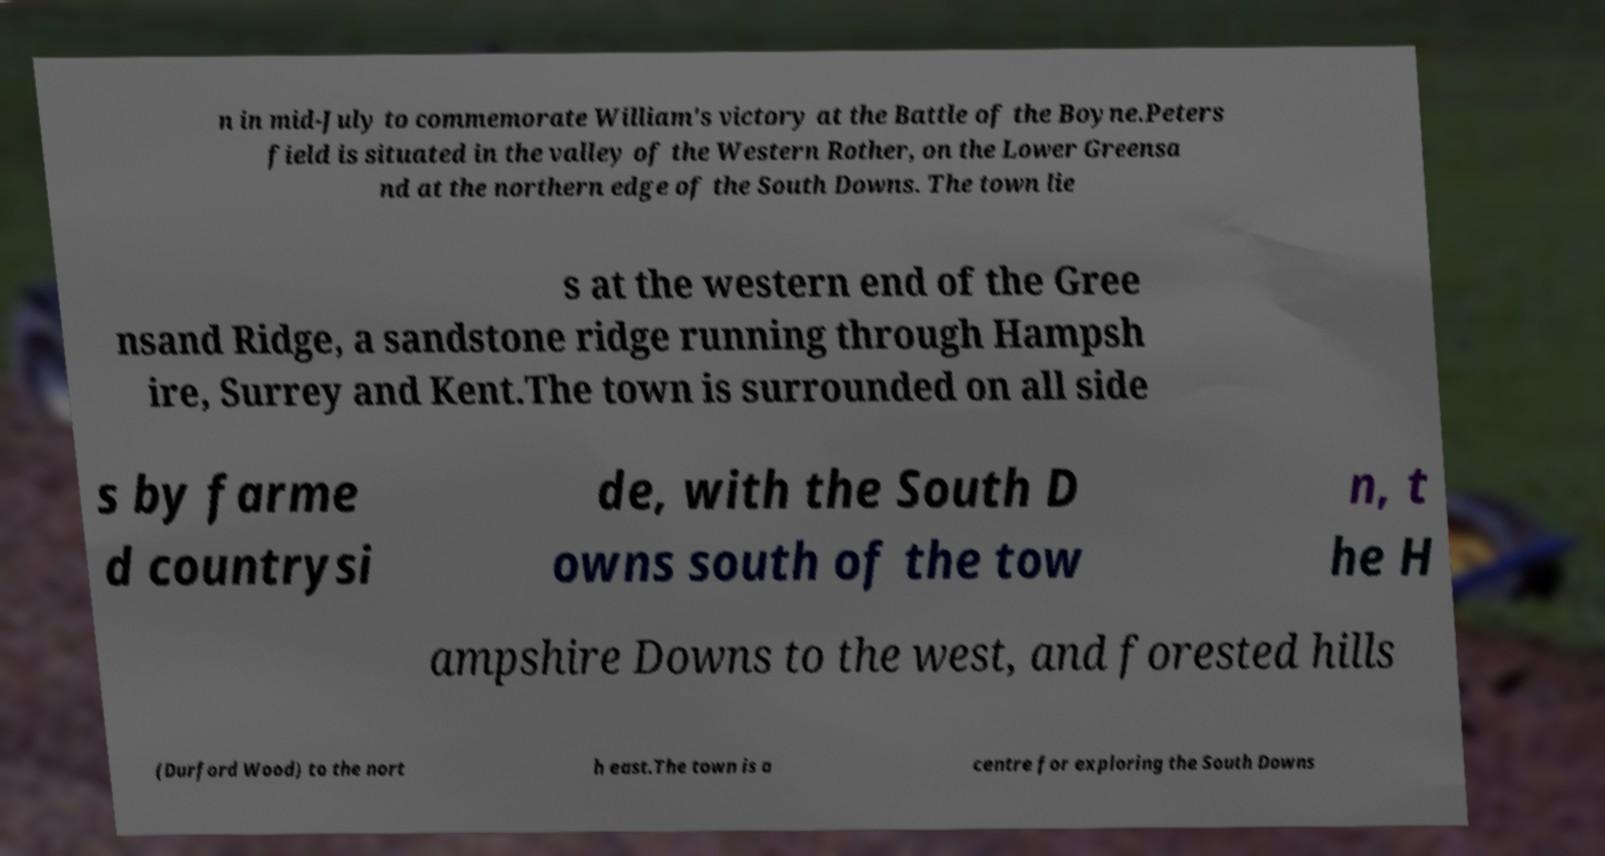There's text embedded in this image that I need extracted. Can you transcribe it verbatim? n in mid-July to commemorate William's victory at the Battle of the Boyne.Peters field is situated in the valley of the Western Rother, on the Lower Greensa nd at the northern edge of the South Downs. The town lie s at the western end of the Gree nsand Ridge, a sandstone ridge running through Hampsh ire, Surrey and Kent.The town is surrounded on all side s by farme d countrysi de, with the South D owns south of the tow n, t he H ampshire Downs to the west, and forested hills (Durford Wood) to the nort h east.The town is a centre for exploring the South Downs 